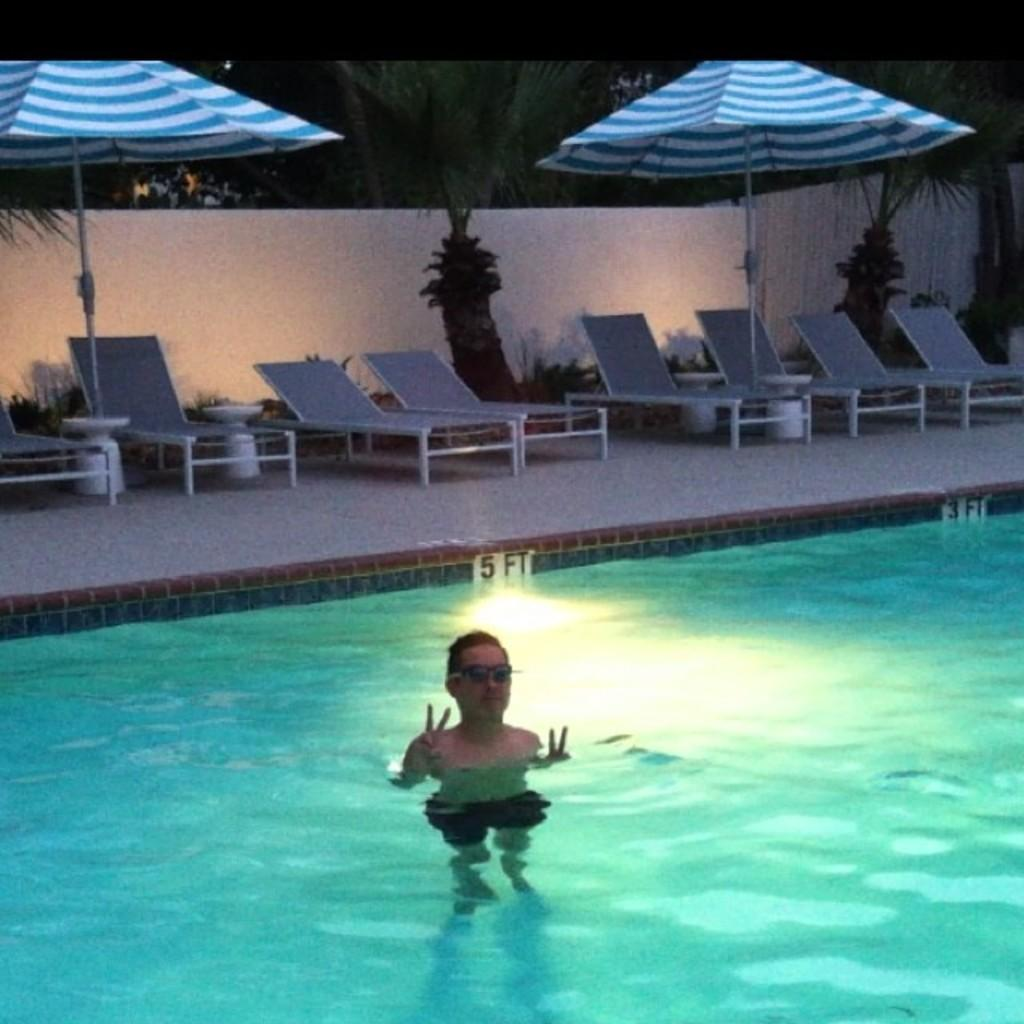What is the person in the image doing? The person is in a water body, which is a swimming pool. What objects are visible in the background of the image? There are pool chairs, an umbrella, plants, and trees in the background. What feature surrounds the swimming pool? There is a boundary around the swimming pool. What type of pot is being used by the person in the image? There is no pot present in the image; the person is in a swimming pool. How many hands does the person in the image have? The image does not show the person's hands, so it is impossible to determine the number of hands they have. 